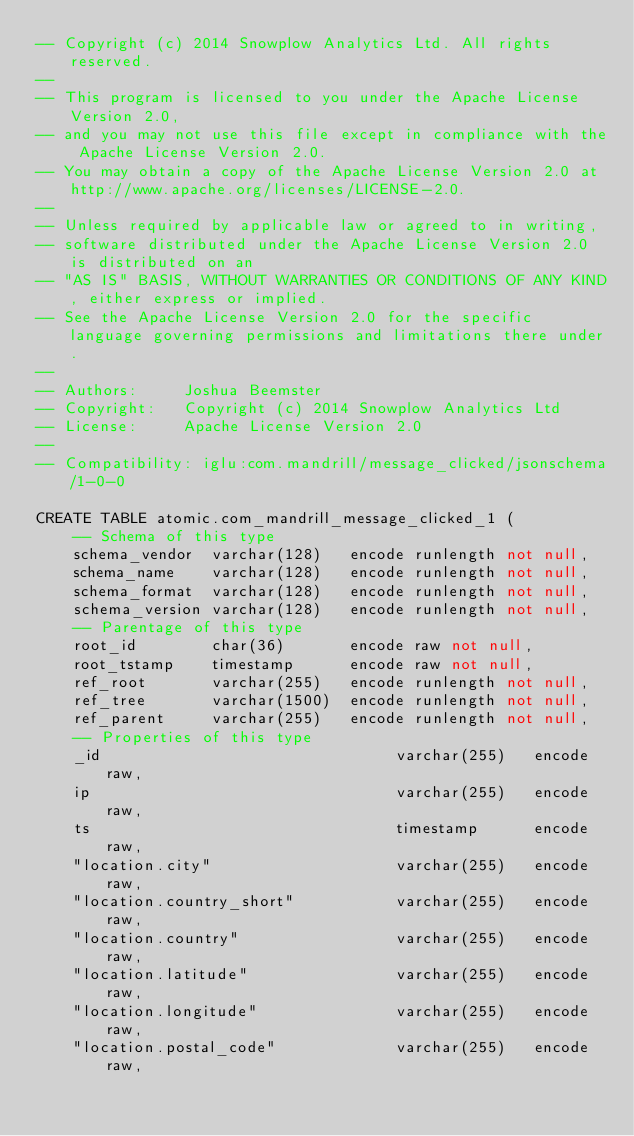<code> <loc_0><loc_0><loc_500><loc_500><_SQL_>-- Copyright (c) 2014 Snowplow Analytics Ltd. All rights reserved.
-- 
-- This program is licensed to you under the Apache License Version 2.0,
-- and you may not use this file except in compliance with the Apache License Version 2.0.
-- You may obtain a copy of the Apache License Version 2.0 at http://www.apache.org/licenses/LICENSE-2.0.
-- 
-- Unless required by applicable law or agreed to in writing,
-- software distributed under the Apache License Version 2.0 is distributed on an
-- "AS IS" BASIS, WITHOUT WARRANTIES OR CONDITIONS OF ANY KIND, either express or implied.
-- See the Apache License Version 2.0 for the specific language governing permissions and limitations there under.
-- 
-- Authors:     Joshua Beemster
-- Copyright:   Copyright (c) 2014 Snowplow Analytics Ltd
-- License:     Apache License Version 2.0
-- 
-- Compatibility: iglu:com.mandrill/message_clicked/jsonschema/1-0-0

CREATE TABLE atomic.com_mandrill_message_clicked_1 (
    -- Schema of this type
    schema_vendor  varchar(128)   encode runlength not null,
    schema_name    varchar(128)   encode runlength not null,
    schema_format  varchar(128)   encode runlength not null,
    schema_version varchar(128)   encode runlength not null,
    -- Parentage of this type
    root_id        char(36)       encode raw not null,
    root_tstamp    timestamp      encode raw not null,
    ref_root       varchar(255)   encode runlength not null,
    ref_tree       varchar(1500)  encode runlength not null,
    ref_parent     varchar(255)   encode runlength not null,
    -- Properties of this type
    _id                                varchar(255)   encode raw,
    ip                                 varchar(255)   encode raw,
    ts                                 timestamp      encode raw,
    "location.city"                    varchar(255)   encode raw,
    "location.country_short"           varchar(255)   encode raw,
    "location.country"                 varchar(255)   encode raw,
    "location.latitude"                varchar(255)   encode raw,
    "location.longitude"               varchar(255)   encode raw,
    "location.postal_code"             varchar(255)   encode raw,</code> 